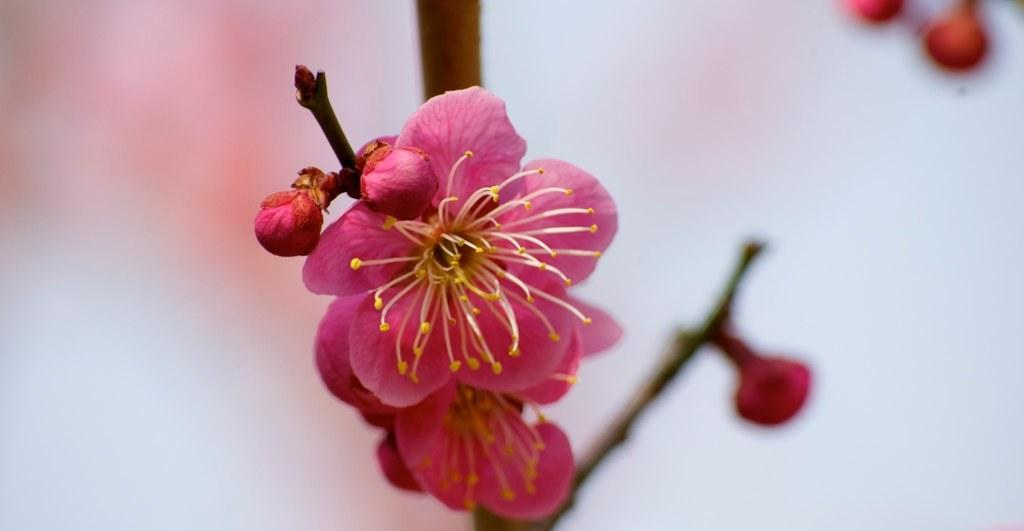What type of plants are in the image? There are flowers in the image. Can you describe the flowers' growth stage? The flowers have buds on the stems. How would you characterize the background of the image? The background of the image is blurry. Can you see a snake slithering through the flowers in the image? There is no snake present in the image; it only features flowers with buds on the stems. 